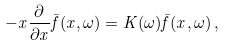Convert formula to latex. <formula><loc_0><loc_0><loc_500><loc_500>- x \frac { \partial } { \partial x } { \bar { f } } ( x , \omega ) = K ( \omega ) { \bar { f } } ( x , \omega ) \, ,</formula> 